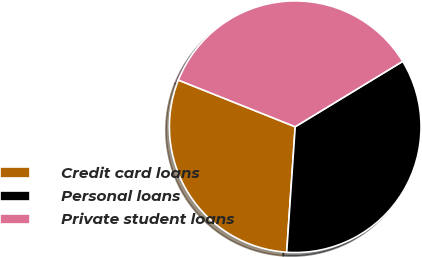Convert chart. <chart><loc_0><loc_0><loc_500><loc_500><pie_chart><fcel>Credit card loans<fcel>Personal loans<fcel>Private student loans<nl><fcel>29.97%<fcel>34.78%<fcel>35.26%<nl></chart> 